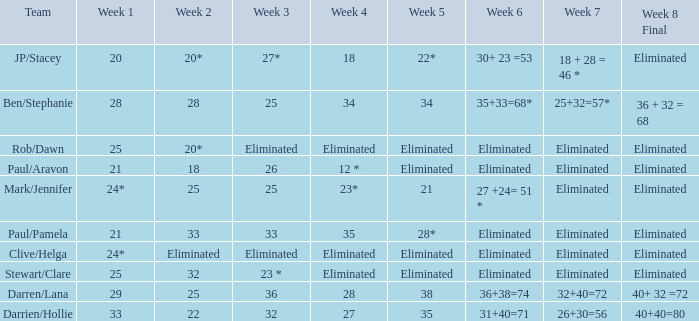Name the week 3 with week 6 of 31+40=71 32.0. 